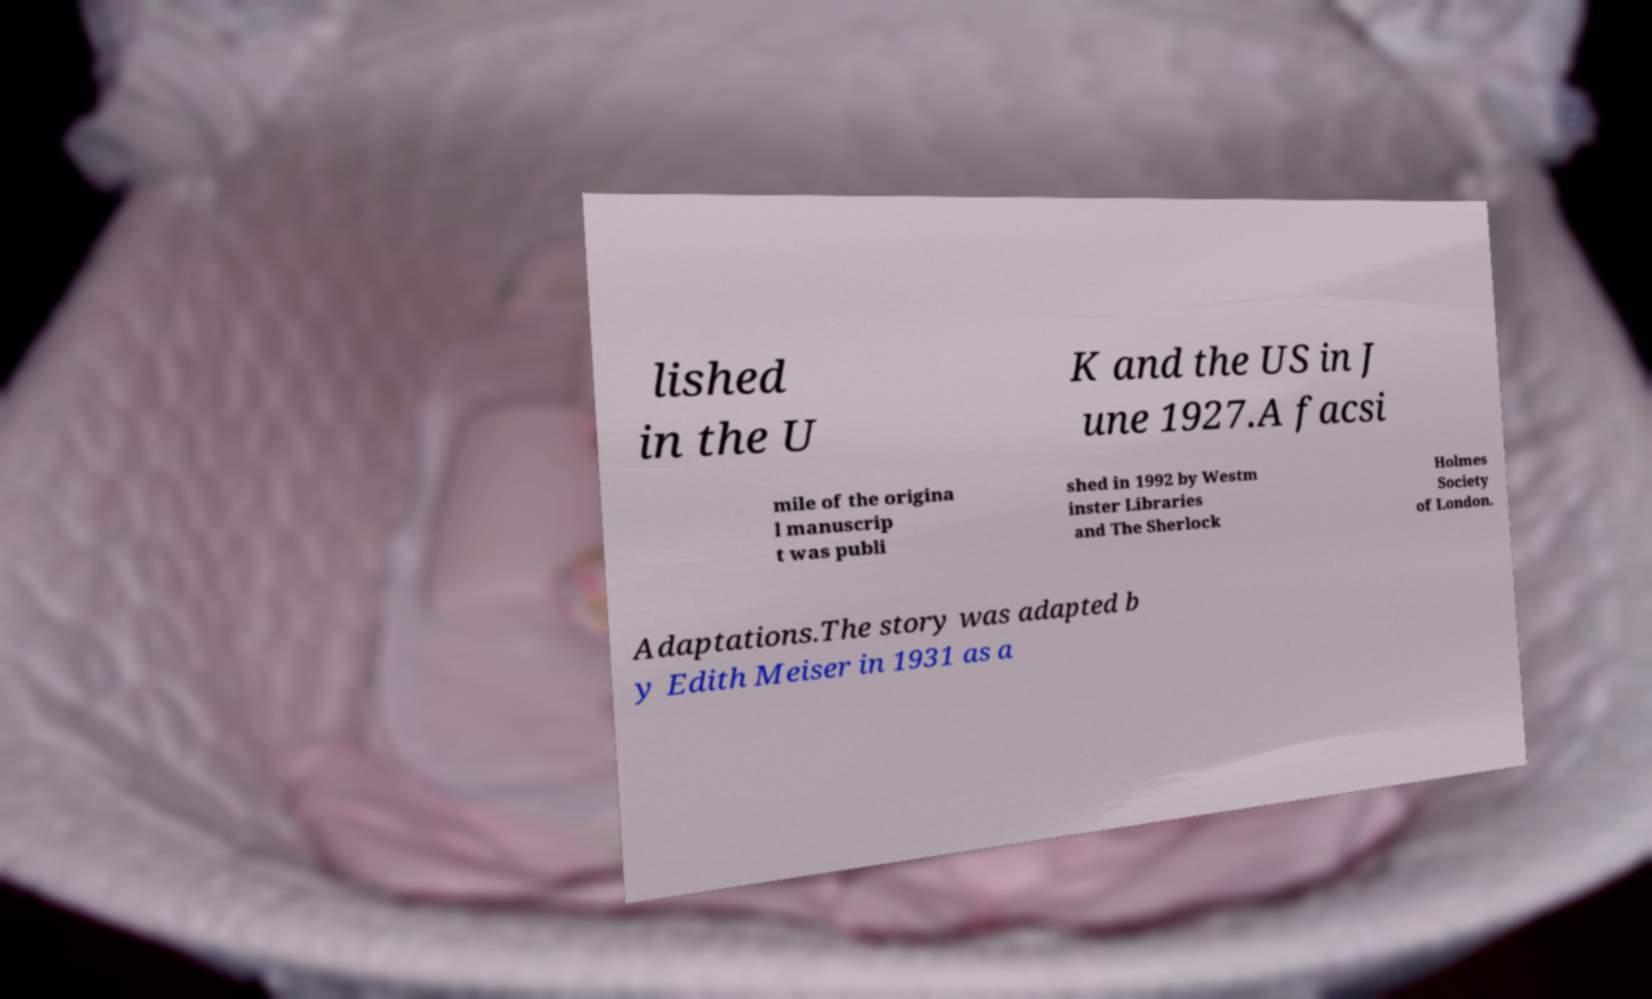Could you extract and type out the text from this image? lished in the U K and the US in J une 1927.A facsi mile of the origina l manuscrip t was publi shed in 1992 by Westm inster Libraries and The Sherlock Holmes Society of London. Adaptations.The story was adapted b y Edith Meiser in 1931 as a 